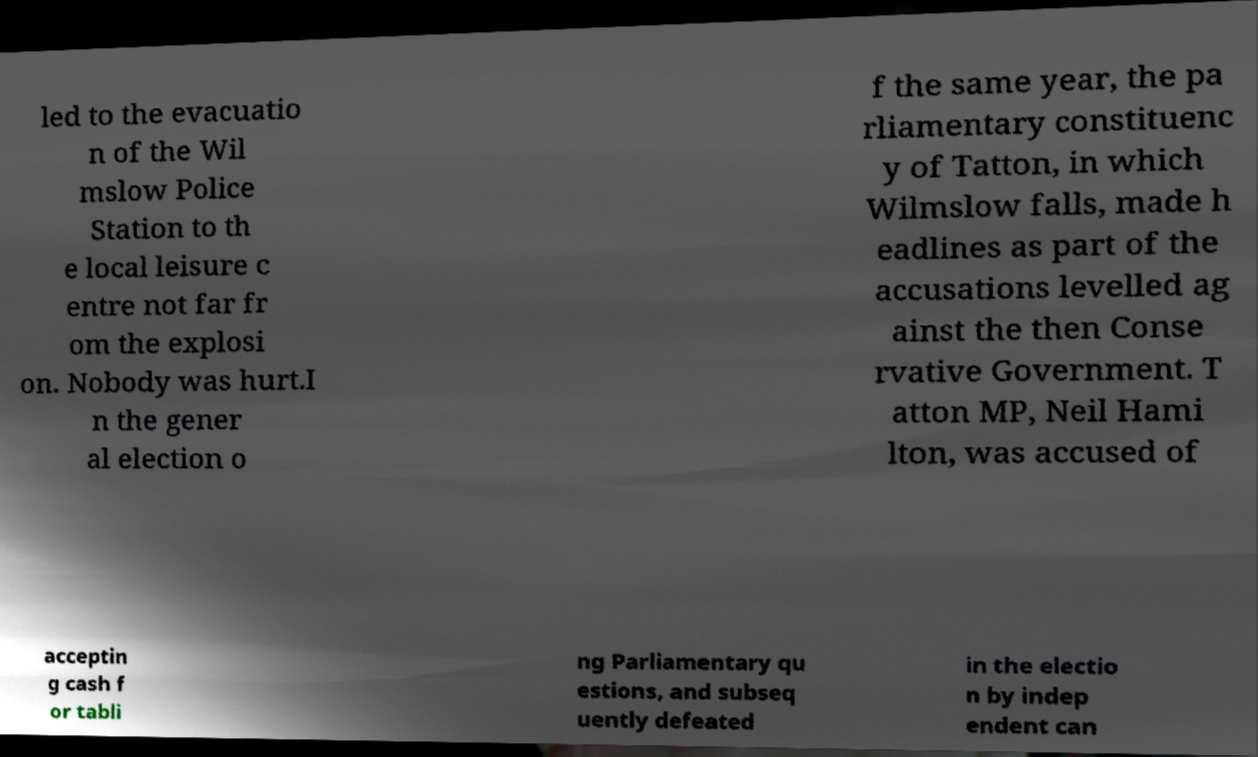Please identify and transcribe the text found in this image. led to the evacuatio n of the Wil mslow Police Station to th e local leisure c entre not far fr om the explosi on. Nobody was hurt.I n the gener al election o f the same year, the pa rliamentary constituenc y of Tatton, in which Wilmslow falls, made h eadlines as part of the accusations levelled ag ainst the then Conse rvative Government. T atton MP, Neil Hami lton, was accused of acceptin g cash f or tabli ng Parliamentary qu estions, and subseq uently defeated in the electio n by indep endent can 